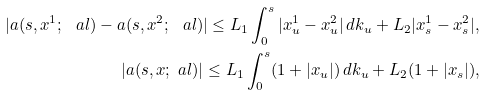Convert formula to latex. <formula><loc_0><loc_0><loc_500><loc_500>| a ( s , x ^ { 1 } ; \ a l ) - a ( s , x ^ { 2 } ; \ a l ) | \leq L _ { 1 } \int _ { 0 } ^ { s } | x _ { u } ^ { 1 } - x _ { u } ^ { 2 } | \, d k _ { u } + L _ { 2 } | x _ { s } ^ { 1 } - x _ { s } ^ { 2 } | , \\ | a ( s , x ; \ a l ) | \leq L _ { 1 } \int _ { 0 } ^ { s } ( 1 + | x _ { u } | ) \, d k _ { u } + L _ { 2 } ( 1 + | x _ { s } | ) ,</formula> 